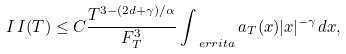<formula> <loc_0><loc_0><loc_500><loc_500>I \, I ( T ) \leq C \frac { T ^ { 3 - ( 2 d + \gamma ) / \alpha } } { F ^ { 3 } _ { T } } \int _ { \ e r r i t a } a _ { T } ( x ) | x | ^ { - \gamma } d x ,</formula> 